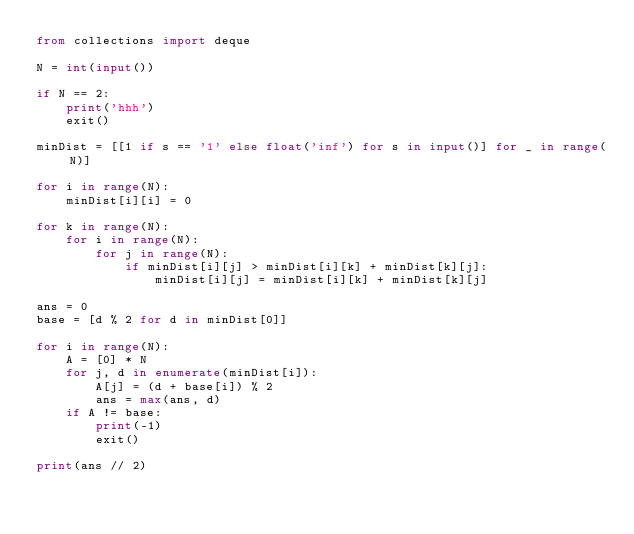<code> <loc_0><loc_0><loc_500><loc_500><_Python_>from collections import deque

N = int(input())

if N == 2:
    print('hhh')
    exit()

minDist = [[1 if s == '1' else float('inf') for s in input()] for _ in range(N)]

for i in range(N):
    minDist[i][i] = 0

for k in range(N):
    for i in range(N):
        for j in range(N):
            if minDist[i][j] > minDist[i][k] + minDist[k][j]:
                minDist[i][j] = minDist[i][k] + minDist[k][j]

ans = 0
base = [d % 2 for d in minDist[0]]

for i in range(N):
    A = [0] * N
    for j, d in enumerate(minDist[i]):
        A[j] = (d + base[i]) % 2
        ans = max(ans, d)
    if A != base:
        print(-1)
        exit()

print(ans // 2)</code> 